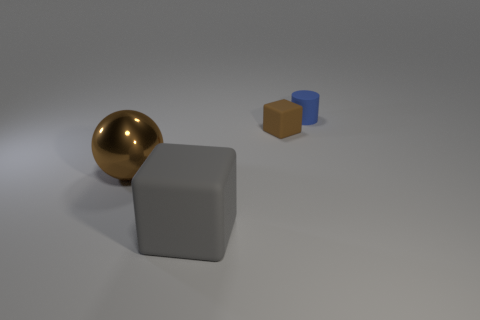What size is the brown thing on the right side of the big brown metal ball?
Make the answer very short. Small. What is the material of the small brown object that is the same shape as the big matte thing?
Keep it short and to the point. Rubber. What is the shape of the small rubber object that is in front of the blue thing?
Your response must be concise. Cube. How many other gray matte objects are the same shape as the large gray thing?
Your response must be concise. 0. Are there an equal number of matte cylinders in front of the big gray matte block and tiny blue cylinders right of the rubber cylinder?
Provide a succinct answer. Yes. Is there a large purple cube that has the same material as the large gray block?
Offer a terse response. No. Does the cylinder have the same material as the gray block?
Your response must be concise. Yes. How many blue things are either tiny matte objects or tiny blocks?
Provide a short and direct response. 1. Is the number of things in front of the blue object greater than the number of small rubber blocks?
Give a very brief answer. Yes. Is there a shiny object of the same color as the small cylinder?
Your answer should be very brief. No. 